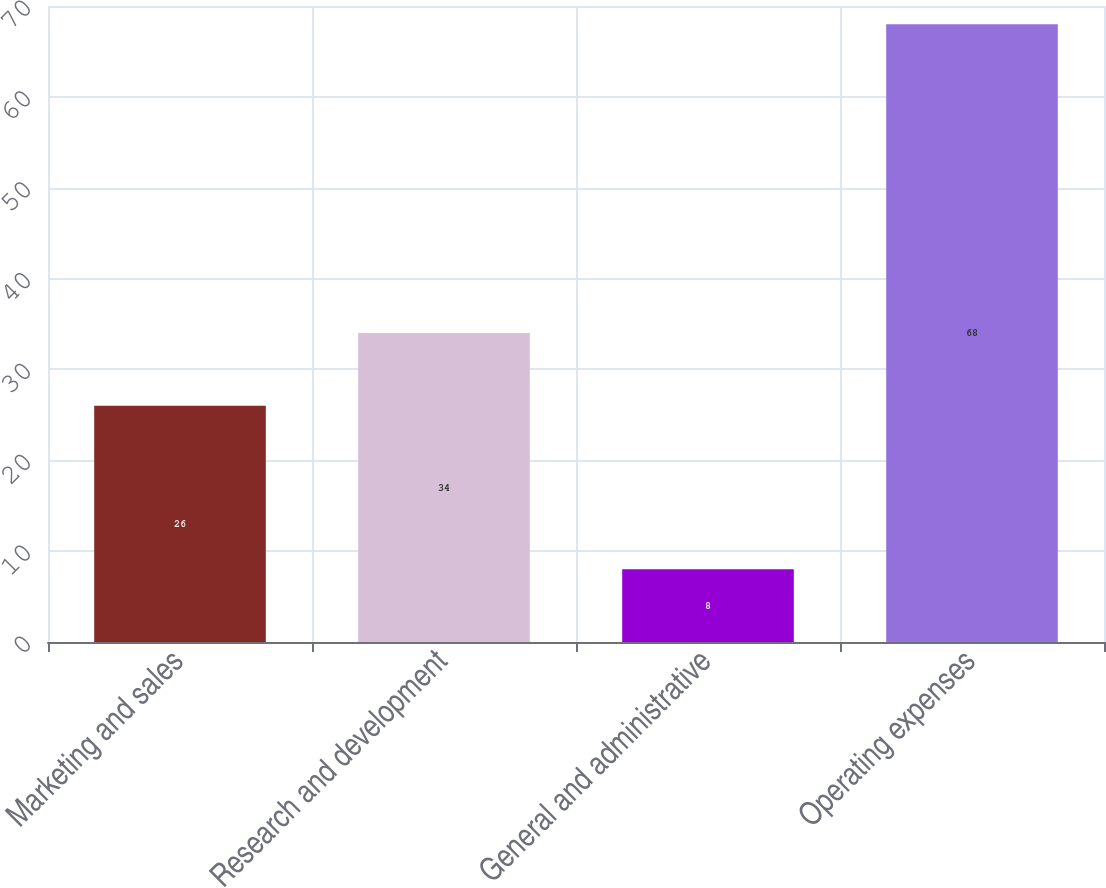Convert chart. <chart><loc_0><loc_0><loc_500><loc_500><bar_chart><fcel>Marketing and sales<fcel>Research and development<fcel>General and administrative<fcel>Operating expenses<nl><fcel>26<fcel>34<fcel>8<fcel>68<nl></chart> 